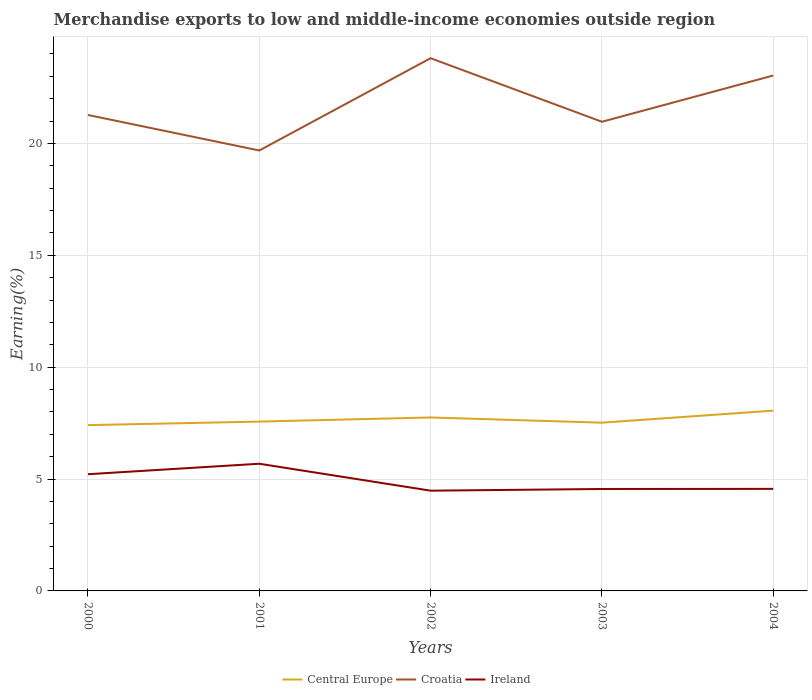How many different coloured lines are there?
Your answer should be compact. 3. Across all years, what is the maximum percentage of amount earned from merchandise exports in Central Europe?
Offer a terse response. 7.41. What is the total percentage of amount earned from merchandise exports in Croatia in the graph?
Your answer should be very brief. -4.12. What is the difference between the highest and the second highest percentage of amount earned from merchandise exports in Ireland?
Your response must be concise. 1.2. What is the difference between the highest and the lowest percentage of amount earned from merchandise exports in Croatia?
Ensure brevity in your answer.  2. How many years are there in the graph?
Ensure brevity in your answer.  5. Does the graph contain grids?
Make the answer very short. Yes. How many legend labels are there?
Your response must be concise. 3. How are the legend labels stacked?
Your response must be concise. Horizontal. What is the title of the graph?
Ensure brevity in your answer.  Merchandise exports to low and middle-income economies outside region. What is the label or title of the X-axis?
Your answer should be very brief. Years. What is the label or title of the Y-axis?
Your response must be concise. Earning(%). What is the Earning(%) of Central Europe in 2000?
Your response must be concise. 7.41. What is the Earning(%) in Croatia in 2000?
Ensure brevity in your answer.  21.27. What is the Earning(%) in Ireland in 2000?
Provide a succinct answer. 5.22. What is the Earning(%) in Central Europe in 2001?
Your answer should be very brief. 7.57. What is the Earning(%) in Croatia in 2001?
Provide a short and direct response. 19.68. What is the Earning(%) of Ireland in 2001?
Offer a terse response. 5.68. What is the Earning(%) of Central Europe in 2002?
Your response must be concise. 7.75. What is the Earning(%) in Croatia in 2002?
Offer a terse response. 23.81. What is the Earning(%) of Ireland in 2002?
Ensure brevity in your answer.  4.48. What is the Earning(%) in Central Europe in 2003?
Your answer should be compact. 7.52. What is the Earning(%) in Croatia in 2003?
Keep it short and to the point. 20.97. What is the Earning(%) of Ireland in 2003?
Offer a terse response. 4.56. What is the Earning(%) of Central Europe in 2004?
Make the answer very short. 8.06. What is the Earning(%) of Croatia in 2004?
Ensure brevity in your answer.  23.03. What is the Earning(%) in Ireland in 2004?
Your answer should be compact. 4.56. Across all years, what is the maximum Earning(%) in Central Europe?
Give a very brief answer. 8.06. Across all years, what is the maximum Earning(%) of Croatia?
Offer a very short reply. 23.81. Across all years, what is the maximum Earning(%) of Ireland?
Your answer should be compact. 5.68. Across all years, what is the minimum Earning(%) in Central Europe?
Your answer should be compact. 7.41. Across all years, what is the minimum Earning(%) in Croatia?
Offer a very short reply. 19.68. Across all years, what is the minimum Earning(%) of Ireland?
Your answer should be compact. 4.48. What is the total Earning(%) of Central Europe in the graph?
Your answer should be compact. 38.31. What is the total Earning(%) of Croatia in the graph?
Your answer should be very brief. 108.77. What is the total Earning(%) of Ireland in the graph?
Provide a short and direct response. 24.5. What is the difference between the Earning(%) of Central Europe in 2000 and that in 2001?
Provide a succinct answer. -0.16. What is the difference between the Earning(%) of Croatia in 2000 and that in 2001?
Offer a terse response. 1.59. What is the difference between the Earning(%) of Ireland in 2000 and that in 2001?
Provide a short and direct response. -0.47. What is the difference between the Earning(%) of Central Europe in 2000 and that in 2002?
Keep it short and to the point. -0.34. What is the difference between the Earning(%) of Croatia in 2000 and that in 2002?
Give a very brief answer. -2.54. What is the difference between the Earning(%) of Ireland in 2000 and that in 2002?
Make the answer very short. 0.74. What is the difference between the Earning(%) of Central Europe in 2000 and that in 2003?
Give a very brief answer. -0.11. What is the difference between the Earning(%) in Croatia in 2000 and that in 2003?
Offer a terse response. 0.3. What is the difference between the Earning(%) of Ireland in 2000 and that in 2003?
Provide a short and direct response. 0.66. What is the difference between the Earning(%) of Central Europe in 2000 and that in 2004?
Offer a terse response. -0.65. What is the difference between the Earning(%) of Croatia in 2000 and that in 2004?
Your answer should be compact. -1.76. What is the difference between the Earning(%) of Ireland in 2000 and that in 2004?
Your answer should be very brief. 0.66. What is the difference between the Earning(%) in Central Europe in 2001 and that in 2002?
Provide a short and direct response. -0.18. What is the difference between the Earning(%) in Croatia in 2001 and that in 2002?
Provide a short and direct response. -4.12. What is the difference between the Earning(%) of Ireland in 2001 and that in 2002?
Offer a terse response. 1.2. What is the difference between the Earning(%) of Central Europe in 2001 and that in 2003?
Make the answer very short. 0.05. What is the difference between the Earning(%) in Croatia in 2001 and that in 2003?
Provide a short and direct response. -1.28. What is the difference between the Earning(%) of Ireland in 2001 and that in 2003?
Your answer should be very brief. 1.13. What is the difference between the Earning(%) of Central Europe in 2001 and that in 2004?
Keep it short and to the point. -0.49. What is the difference between the Earning(%) of Croatia in 2001 and that in 2004?
Your response must be concise. -3.35. What is the difference between the Earning(%) in Ireland in 2001 and that in 2004?
Offer a terse response. 1.12. What is the difference between the Earning(%) in Central Europe in 2002 and that in 2003?
Make the answer very short. 0.23. What is the difference between the Earning(%) of Croatia in 2002 and that in 2003?
Your answer should be very brief. 2.84. What is the difference between the Earning(%) in Ireland in 2002 and that in 2003?
Ensure brevity in your answer.  -0.08. What is the difference between the Earning(%) in Central Europe in 2002 and that in 2004?
Offer a terse response. -0.3. What is the difference between the Earning(%) of Croatia in 2002 and that in 2004?
Make the answer very short. 0.77. What is the difference between the Earning(%) of Ireland in 2002 and that in 2004?
Your answer should be very brief. -0.08. What is the difference between the Earning(%) of Central Europe in 2003 and that in 2004?
Your answer should be compact. -0.54. What is the difference between the Earning(%) in Croatia in 2003 and that in 2004?
Offer a terse response. -2.07. What is the difference between the Earning(%) in Ireland in 2003 and that in 2004?
Your answer should be compact. -0. What is the difference between the Earning(%) of Central Europe in 2000 and the Earning(%) of Croatia in 2001?
Your answer should be very brief. -12.27. What is the difference between the Earning(%) of Central Europe in 2000 and the Earning(%) of Ireland in 2001?
Offer a terse response. 1.73. What is the difference between the Earning(%) in Croatia in 2000 and the Earning(%) in Ireland in 2001?
Your answer should be compact. 15.59. What is the difference between the Earning(%) of Central Europe in 2000 and the Earning(%) of Croatia in 2002?
Your answer should be compact. -16.4. What is the difference between the Earning(%) in Central Europe in 2000 and the Earning(%) in Ireland in 2002?
Ensure brevity in your answer.  2.93. What is the difference between the Earning(%) of Croatia in 2000 and the Earning(%) of Ireland in 2002?
Offer a very short reply. 16.79. What is the difference between the Earning(%) of Central Europe in 2000 and the Earning(%) of Croatia in 2003?
Give a very brief answer. -13.56. What is the difference between the Earning(%) in Central Europe in 2000 and the Earning(%) in Ireland in 2003?
Offer a terse response. 2.85. What is the difference between the Earning(%) in Croatia in 2000 and the Earning(%) in Ireland in 2003?
Keep it short and to the point. 16.72. What is the difference between the Earning(%) of Central Europe in 2000 and the Earning(%) of Croatia in 2004?
Your response must be concise. -15.63. What is the difference between the Earning(%) of Central Europe in 2000 and the Earning(%) of Ireland in 2004?
Provide a short and direct response. 2.85. What is the difference between the Earning(%) of Croatia in 2000 and the Earning(%) of Ireland in 2004?
Offer a very short reply. 16.71. What is the difference between the Earning(%) of Central Europe in 2001 and the Earning(%) of Croatia in 2002?
Keep it short and to the point. -16.24. What is the difference between the Earning(%) in Central Europe in 2001 and the Earning(%) in Ireland in 2002?
Your answer should be very brief. 3.09. What is the difference between the Earning(%) of Croatia in 2001 and the Earning(%) of Ireland in 2002?
Your answer should be compact. 15.2. What is the difference between the Earning(%) in Central Europe in 2001 and the Earning(%) in Croatia in 2003?
Give a very brief answer. -13.4. What is the difference between the Earning(%) of Central Europe in 2001 and the Earning(%) of Ireland in 2003?
Provide a succinct answer. 3.01. What is the difference between the Earning(%) of Croatia in 2001 and the Earning(%) of Ireland in 2003?
Your response must be concise. 15.13. What is the difference between the Earning(%) of Central Europe in 2001 and the Earning(%) of Croatia in 2004?
Provide a succinct answer. -15.47. What is the difference between the Earning(%) in Central Europe in 2001 and the Earning(%) in Ireland in 2004?
Make the answer very short. 3.01. What is the difference between the Earning(%) of Croatia in 2001 and the Earning(%) of Ireland in 2004?
Your answer should be very brief. 15.12. What is the difference between the Earning(%) of Central Europe in 2002 and the Earning(%) of Croatia in 2003?
Your answer should be very brief. -13.22. What is the difference between the Earning(%) of Central Europe in 2002 and the Earning(%) of Ireland in 2003?
Your response must be concise. 3.2. What is the difference between the Earning(%) of Croatia in 2002 and the Earning(%) of Ireland in 2003?
Your answer should be compact. 19.25. What is the difference between the Earning(%) of Central Europe in 2002 and the Earning(%) of Croatia in 2004?
Your answer should be compact. -15.28. What is the difference between the Earning(%) of Central Europe in 2002 and the Earning(%) of Ireland in 2004?
Your answer should be very brief. 3.19. What is the difference between the Earning(%) of Croatia in 2002 and the Earning(%) of Ireland in 2004?
Your answer should be very brief. 19.25. What is the difference between the Earning(%) in Central Europe in 2003 and the Earning(%) in Croatia in 2004?
Give a very brief answer. -15.52. What is the difference between the Earning(%) of Central Europe in 2003 and the Earning(%) of Ireland in 2004?
Your answer should be very brief. 2.96. What is the difference between the Earning(%) of Croatia in 2003 and the Earning(%) of Ireland in 2004?
Ensure brevity in your answer.  16.41. What is the average Earning(%) in Central Europe per year?
Offer a very short reply. 7.66. What is the average Earning(%) of Croatia per year?
Provide a succinct answer. 21.75. What is the average Earning(%) of Ireland per year?
Make the answer very short. 4.9. In the year 2000, what is the difference between the Earning(%) of Central Europe and Earning(%) of Croatia?
Keep it short and to the point. -13.86. In the year 2000, what is the difference between the Earning(%) of Central Europe and Earning(%) of Ireland?
Offer a terse response. 2.19. In the year 2000, what is the difference between the Earning(%) in Croatia and Earning(%) in Ireland?
Your answer should be very brief. 16.05. In the year 2001, what is the difference between the Earning(%) in Central Europe and Earning(%) in Croatia?
Your answer should be compact. -12.12. In the year 2001, what is the difference between the Earning(%) in Central Europe and Earning(%) in Ireland?
Ensure brevity in your answer.  1.88. In the year 2001, what is the difference between the Earning(%) in Croatia and Earning(%) in Ireland?
Offer a terse response. 14. In the year 2002, what is the difference between the Earning(%) in Central Europe and Earning(%) in Croatia?
Your response must be concise. -16.06. In the year 2002, what is the difference between the Earning(%) in Central Europe and Earning(%) in Ireland?
Your response must be concise. 3.27. In the year 2002, what is the difference between the Earning(%) of Croatia and Earning(%) of Ireland?
Offer a very short reply. 19.33. In the year 2003, what is the difference between the Earning(%) in Central Europe and Earning(%) in Croatia?
Your answer should be compact. -13.45. In the year 2003, what is the difference between the Earning(%) of Central Europe and Earning(%) of Ireland?
Keep it short and to the point. 2.96. In the year 2003, what is the difference between the Earning(%) in Croatia and Earning(%) in Ireland?
Make the answer very short. 16.41. In the year 2004, what is the difference between the Earning(%) of Central Europe and Earning(%) of Croatia?
Provide a short and direct response. -14.98. In the year 2004, what is the difference between the Earning(%) in Central Europe and Earning(%) in Ireland?
Provide a succinct answer. 3.5. In the year 2004, what is the difference between the Earning(%) of Croatia and Earning(%) of Ireland?
Your answer should be very brief. 18.47. What is the ratio of the Earning(%) in Central Europe in 2000 to that in 2001?
Provide a short and direct response. 0.98. What is the ratio of the Earning(%) in Croatia in 2000 to that in 2001?
Provide a short and direct response. 1.08. What is the ratio of the Earning(%) of Ireland in 2000 to that in 2001?
Keep it short and to the point. 0.92. What is the ratio of the Earning(%) in Central Europe in 2000 to that in 2002?
Your answer should be very brief. 0.96. What is the ratio of the Earning(%) of Croatia in 2000 to that in 2002?
Offer a very short reply. 0.89. What is the ratio of the Earning(%) in Ireland in 2000 to that in 2002?
Make the answer very short. 1.16. What is the ratio of the Earning(%) of Central Europe in 2000 to that in 2003?
Offer a very short reply. 0.99. What is the ratio of the Earning(%) in Croatia in 2000 to that in 2003?
Offer a very short reply. 1.01. What is the ratio of the Earning(%) in Ireland in 2000 to that in 2003?
Provide a short and direct response. 1.15. What is the ratio of the Earning(%) of Central Europe in 2000 to that in 2004?
Provide a short and direct response. 0.92. What is the ratio of the Earning(%) in Croatia in 2000 to that in 2004?
Your response must be concise. 0.92. What is the ratio of the Earning(%) in Ireland in 2000 to that in 2004?
Provide a succinct answer. 1.14. What is the ratio of the Earning(%) in Central Europe in 2001 to that in 2002?
Ensure brevity in your answer.  0.98. What is the ratio of the Earning(%) of Croatia in 2001 to that in 2002?
Provide a succinct answer. 0.83. What is the ratio of the Earning(%) in Ireland in 2001 to that in 2002?
Offer a terse response. 1.27. What is the ratio of the Earning(%) of Central Europe in 2001 to that in 2003?
Offer a terse response. 1.01. What is the ratio of the Earning(%) in Croatia in 2001 to that in 2003?
Keep it short and to the point. 0.94. What is the ratio of the Earning(%) in Ireland in 2001 to that in 2003?
Offer a terse response. 1.25. What is the ratio of the Earning(%) of Central Europe in 2001 to that in 2004?
Offer a very short reply. 0.94. What is the ratio of the Earning(%) of Croatia in 2001 to that in 2004?
Give a very brief answer. 0.85. What is the ratio of the Earning(%) of Ireland in 2001 to that in 2004?
Provide a succinct answer. 1.25. What is the ratio of the Earning(%) of Central Europe in 2002 to that in 2003?
Give a very brief answer. 1.03. What is the ratio of the Earning(%) in Croatia in 2002 to that in 2003?
Your response must be concise. 1.14. What is the ratio of the Earning(%) of Ireland in 2002 to that in 2003?
Offer a very short reply. 0.98. What is the ratio of the Earning(%) of Central Europe in 2002 to that in 2004?
Give a very brief answer. 0.96. What is the ratio of the Earning(%) in Croatia in 2002 to that in 2004?
Keep it short and to the point. 1.03. What is the ratio of the Earning(%) in Ireland in 2002 to that in 2004?
Your response must be concise. 0.98. What is the ratio of the Earning(%) in Central Europe in 2003 to that in 2004?
Your answer should be very brief. 0.93. What is the ratio of the Earning(%) in Croatia in 2003 to that in 2004?
Keep it short and to the point. 0.91. What is the ratio of the Earning(%) of Ireland in 2003 to that in 2004?
Provide a succinct answer. 1. What is the difference between the highest and the second highest Earning(%) of Central Europe?
Provide a short and direct response. 0.3. What is the difference between the highest and the second highest Earning(%) in Croatia?
Make the answer very short. 0.77. What is the difference between the highest and the second highest Earning(%) of Ireland?
Keep it short and to the point. 0.47. What is the difference between the highest and the lowest Earning(%) in Central Europe?
Offer a terse response. 0.65. What is the difference between the highest and the lowest Earning(%) of Croatia?
Give a very brief answer. 4.12. What is the difference between the highest and the lowest Earning(%) of Ireland?
Your answer should be compact. 1.2. 